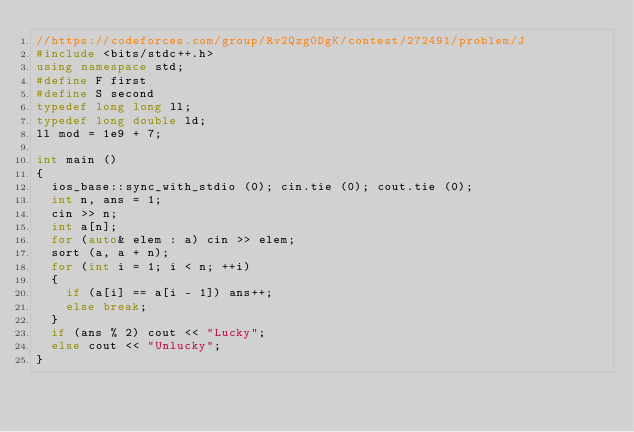Convert code to text. <code><loc_0><loc_0><loc_500><loc_500><_C++_>//https://codeforces.com/group/Rv2Qzg0DgK/contest/272491/problem/J
#include <bits/stdc++.h>
using namespace std;
#define F first 
#define S second
typedef long long ll;
typedef long double ld;
ll mod = 1e9 + 7;

int main ()
{
	ios_base::sync_with_stdio (0); cin.tie (0); cout.tie (0);
	int n, ans = 1;
	cin >> n;
	int a[n];
	for (auto& elem : a) cin >> elem;
	sort (a, a + n);
	for (int i = 1; i < n; ++i)
	{
		if (a[i] == a[i - 1]) ans++;
		else break;
	}
	if (ans % 2) cout << "Lucky";
	else cout << "Unlucky";
}
</code> 